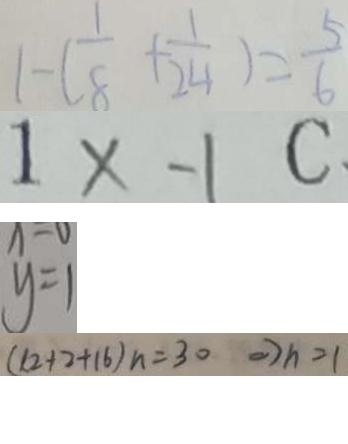Convert formula to latex. <formula><loc_0><loc_0><loc_500><loc_500>1 - ( \frac { 1 } { 8 } + \frac { 1 } { 2 4 } ) = \frac { 5 } { 6 } 
 1 \times - 1 C 
 y = 1 
 ( 1 2 + 2 + 1 6 ) n = 3 0 \Rightarrow h = 1</formula> 